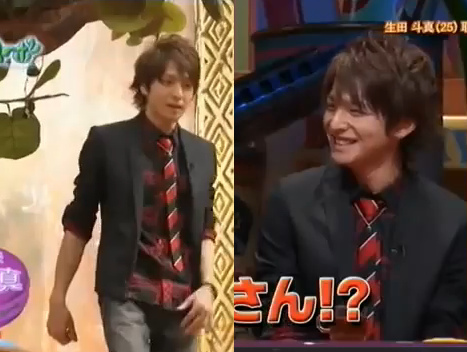<image>What is the name of the president? I don't know what is the name of the president. It could be 'john', 'c h', 'japanese', 'obama', or 'trump'. What is the name of the president? I don't know the name of the president. It can be 'john', 'c h', 'obama', 'trump' or 'unknown'. 